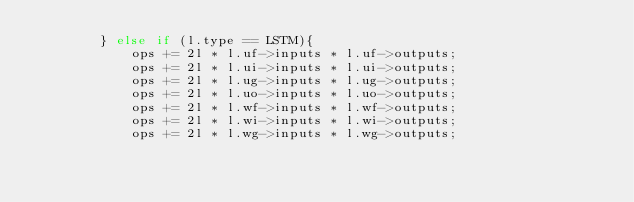<code> <loc_0><loc_0><loc_500><loc_500><_C_>        } else if (l.type == LSTM){
            ops += 2l * l.uf->inputs * l.uf->outputs;
            ops += 2l * l.ui->inputs * l.ui->outputs;
            ops += 2l * l.ug->inputs * l.ug->outputs;
            ops += 2l * l.uo->inputs * l.uo->outputs;
            ops += 2l * l.wf->inputs * l.wf->outputs;
            ops += 2l * l.wi->inputs * l.wi->outputs;
            ops += 2l * l.wg->inputs * l.wg->outputs;</code> 